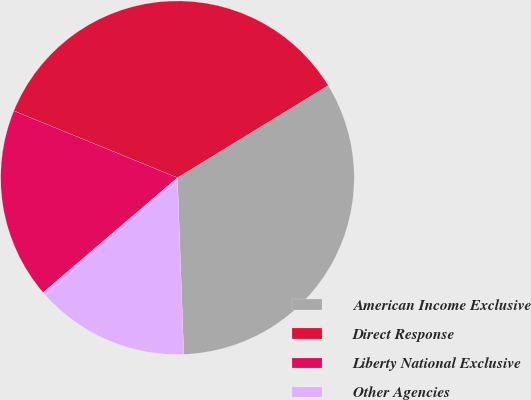<chart> <loc_0><loc_0><loc_500><loc_500><pie_chart><fcel>American Income Exclusive<fcel>Direct Response<fcel>Liberty National Exclusive<fcel>Other Agencies<nl><fcel>33.17%<fcel>35.09%<fcel>17.43%<fcel>14.31%<nl></chart> 